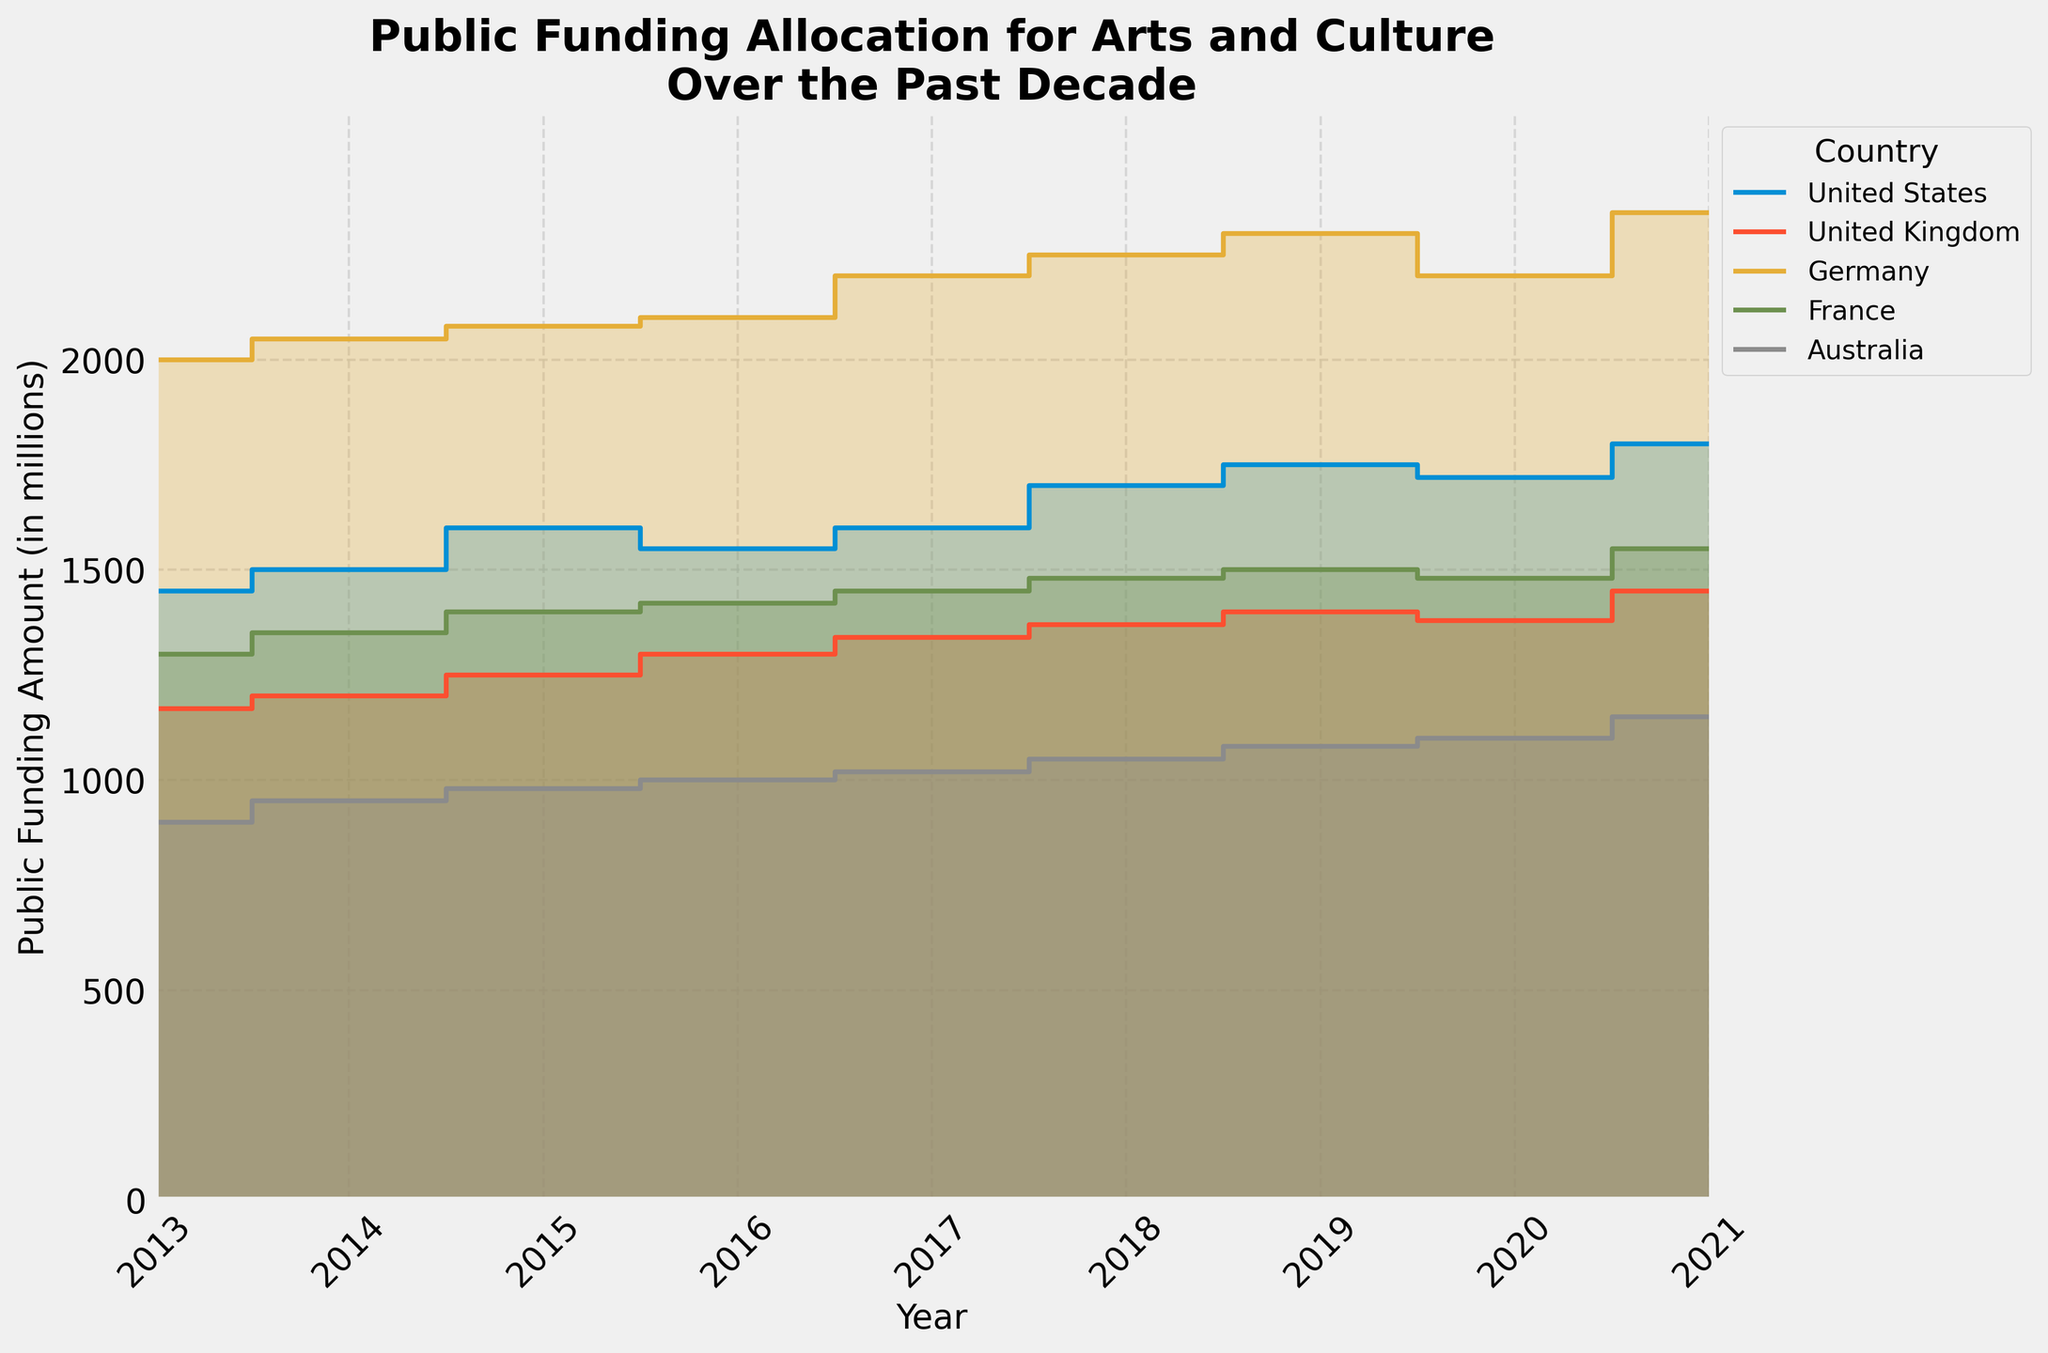How many countries are represented in the chart? The legend of the chart lists the countries involved. Each country has its own color and label, indicating how many countries' data are presented.
Answer: 5 What is the highest public funding amount recorded for the United States over the past decade? Identify the step on the chart where the funding amount for the United States is at its highest point and read off the corresponding value.
Answer: 1800 million Between 2019 and 2020, which country saw the largest drop in public funding allocation? Compare the changes in funding allocation for each country between 2019 and 2020. Calculate the difference for all countries and determine which has the largest decrease.
Answer: Germany What is the overall trend of public funding allocation for arts and culture in Australia from 2013 to 2021? Observe the line on the chart representing Australia from the leftmost point in 2013 to the rightmost point in 2021. Note if the line generally increases, decreases, or remains stable.
Answer: Increasing Which country had the highest public funding allocation in 2017? Locate the data points for the year 2017 for each country and compare the public funding amounts to find the highest.
Answer: Germany Did any of the countries experience a decrease in public funding from 2020 to 2021? Check the final step between 2020 and 2021 for each country to see if any lines decrease during this period.
Answer: No What is the average public funding amount for France over the past decade? Sum the public funding amounts for France from 2013 to 2021 and divide by the number of years (9). (1300 + 1350 + 1400 + 1420 + 1450 + 1480 + 1500 + 1480 + 1550) / 9
Answer: 1436.7 million Which year had the smallest variation in public funding amounts among all countries? Assess each year by looking at the range (difference between the highest and lowest funding amounts) for that year, then identify the year with the smallest range.
Answer: 2020 Between the United States and the United Kingdom, which country had a faster growth rate in public funding from 2013 to 2021? Calculate the growth rate for the United States and the United Kingdom by comparing their initial and final funding amounts, then determine which growth rate is higher.
Answer: United Kingdom 